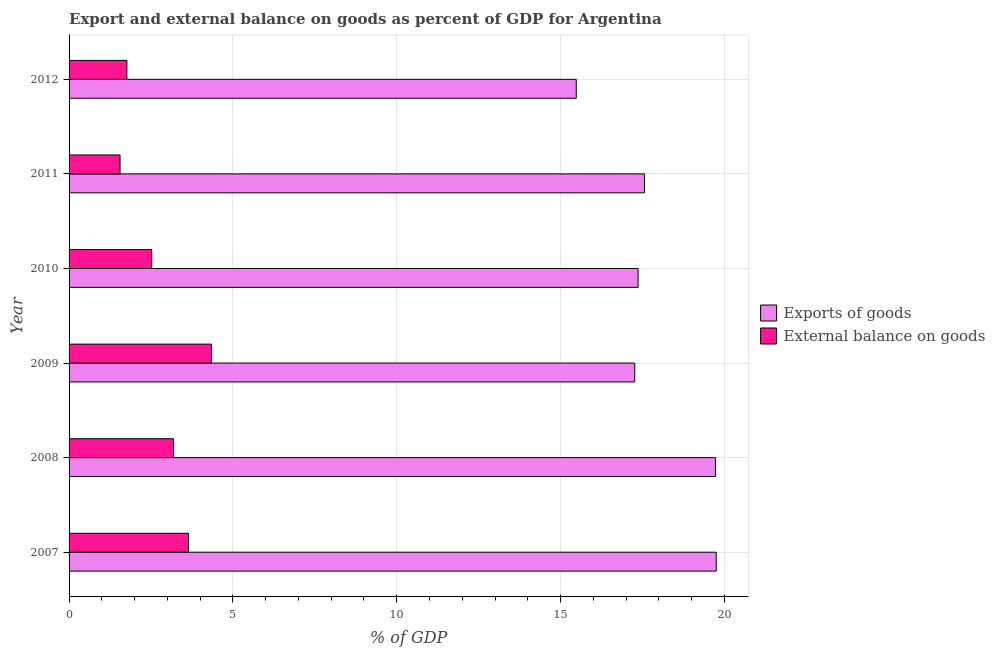How many groups of bars are there?
Offer a terse response. 6. Are the number of bars per tick equal to the number of legend labels?
Give a very brief answer. Yes. Are the number of bars on each tick of the Y-axis equal?
Offer a very short reply. Yes. How many bars are there on the 6th tick from the bottom?
Your answer should be compact. 2. What is the label of the 5th group of bars from the top?
Offer a terse response. 2008. In how many cases, is the number of bars for a given year not equal to the number of legend labels?
Your answer should be very brief. 0. What is the export of goods as percentage of gdp in 2009?
Offer a terse response. 17.27. Across all years, what is the maximum export of goods as percentage of gdp?
Your answer should be compact. 19.75. Across all years, what is the minimum export of goods as percentage of gdp?
Give a very brief answer. 15.48. In which year was the external balance on goods as percentage of gdp maximum?
Your answer should be compact. 2009. In which year was the external balance on goods as percentage of gdp minimum?
Your answer should be very brief. 2011. What is the total export of goods as percentage of gdp in the graph?
Provide a short and direct response. 107.16. What is the difference between the external balance on goods as percentage of gdp in 2008 and that in 2011?
Your answer should be very brief. 1.63. What is the difference between the export of goods as percentage of gdp in 2012 and the external balance on goods as percentage of gdp in 2007?
Give a very brief answer. 11.84. What is the average export of goods as percentage of gdp per year?
Keep it short and to the point. 17.86. In the year 2009, what is the difference between the external balance on goods as percentage of gdp and export of goods as percentage of gdp?
Offer a terse response. -12.92. What is the ratio of the export of goods as percentage of gdp in 2008 to that in 2009?
Your answer should be compact. 1.14. What is the difference between the highest and the second highest external balance on goods as percentage of gdp?
Offer a terse response. 0.7. What is the difference between the highest and the lowest external balance on goods as percentage of gdp?
Ensure brevity in your answer.  2.79. In how many years, is the export of goods as percentage of gdp greater than the average export of goods as percentage of gdp taken over all years?
Your answer should be compact. 2. What does the 1st bar from the top in 2012 represents?
Your answer should be very brief. External balance on goods. What does the 1st bar from the bottom in 2012 represents?
Provide a short and direct response. Exports of goods. Are all the bars in the graph horizontal?
Give a very brief answer. Yes. How many years are there in the graph?
Your answer should be compact. 6. Are the values on the major ticks of X-axis written in scientific E-notation?
Provide a short and direct response. No. Does the graph contain any zero values?
Ensure brevity in your answer.  No. How are the legend labels stacked?
Make the answer very short. Vertical. What is the title of the graph?
Provide a short and direct response. Export and external balance on goods as percent of GDP for Argentina. Does "Electricity and heat production" appear as one of the legend labels in the graph?
Make the answer very short. No. What is the label or title of the X-axis?
Give a very brief answer. % of GDP. What is the label or title of the Y-axis?
Make the answer very short. Year. What is the % of GDP in Exports of goods in 2007?
Give a very brief answer. 19.75. What is the % of GDP of External balance on goods in 2007?
Give a very brief answer. 3.64. What is the % of GDP of Exports of goods in 2008?
Keep it short and to the point. 19.73. What is the % of GDP of External balance on goods in 2008?
Keep it short and to the point. 3.19. What is the % of GDP of Exports of goods in 2009?
Offer a very short reply. 17.27. What is the % of GDP of External balance on goods in 2009?
Give a very brief answer. 4.35. What is the % of GDP of Exports of goods in 2010?
Provide a succinct answer. 17.37. What is the % of GDP in External balance on goods in 2010?
Provide a short and direct response. 2.52. What is the % of GDP in Exports of goods in 2011?
Give a very brief answer. 17.56. What is the % of GDP in External balance on goods in 2011?
Your response must be concise. 1.56. What is the % of GDP in Exports of goods in 2012?
Your response must be concise. 15.48. What is the % of GDP in External balance on goods in 2012?
Your response must be concise. 1.76. Across all years, what is the maximum % of GDP in Exports of goods?
Offer a terse response. 19.75. Across all years, what is the maximum % of GDP of External balance on goods?
Your answer should be very brief. 4.35. Across all years, what is the minimum % of GDP in Exports of goods?
Offer a very short reply. 15.48. Across all years, what is the minimum % of GDP in External balance on goods?
Your answer should be compact. 1.56. What is the total % of GDP of Exports of goods in the graph?
Make the answer very short. 107.16. What is the total % of GDP of External balance on goods in the graph?
Provide a short and direct response. 17.02. What is the difference between the % of GDP in Exports of goods in 2007 and that in 2008?
Make the answer very short. 0.02. What is the difference between the % of GDP of External balance on goods in 2007 and that in 2008?
Make the answer very short. 0.46. What is the difference between the % of GDP of Exports of goods in 2007 and that in 2009?
Make the answer very short. 2.49. What is the difference between the % of GDP of External balance on goods in 2007 and that in 2009?
Give a very brief answer. -0.7. What is the difference between the % of GDP in Exports of goods in 2007 and that in 2010?
Provide a succinct answer. 2.39. What is the difference between the % of GDP in External balance on goods in 2007 and that in 2010?
Provide a succinct answer. 1.12. What is the difference between the % of GDP of Exports of goods in 2007 and that in 2011?
Offer a terse response. 2.19. What is the difference between the % of GDP of External balance on goods in 2007 and that in 2011?
Offer a terse response. 2.09. What is the difference between the % of GDP in Exports of goods in 2007 and that in 2012?
Give a very brief answer. 4.27. What is the difference between the % of GDP in External balance on goods in 2007 and that in 2012?
Give a very brief answer. 1.88. What is the difference between the % of GDP of Exports of goods in 2008 and that in 2009?
Give a very brief answer. 2.46. What is the difference between the % of GDP in External balance on goods in 2008 and that in 2009?
Provide a short and direct response. -1.16. What is the difference between the % of GDP of Exports of goods in 2008 and that in 2010?
Give a very brief answer. 2.36. What is the difference between the % of GDP of External balance on goods in 2008 and that in 2010?
Provide a succinct answer. 0.66. What is the difference between the % of GDP in Exports of goods in 2008 and that in 2011?
Keep it short and to the point. 2.17. What is the difference between the % of GDP in External balance on goods in 2008 and that in 2011?
Ensure brevity in your answer.  1.63. What is the difference between the % of GDP of Exports of goods in 2008 and that in 2012?
Provide a succinct answer. 4.25. What is the difference between the % of GDP in External balance on goods in 2008 and that in 2012?
Offer a terse response. 1.42. What is the difference between the % of GDP of Exports of goods in 2009 and that in 2010?
Make the answer very short. -0.1. What is the difference between the % of GDP of External balance on goods in 2009 and that in 2010?
Offer a very short reply. 1.82. What is the difference between the % of GDP in Exports of goods in 2009 and that in 2011?
Ensure brevity in your answer.  -0.3. What is the difference between the % of GDP of External balance on goods in 2009 and that in 2011?
Make the answer very short. 2.79. What is the difference between the % of GDP of Exports of goods in 2009 and that in 2012?
Your answer should be very brief. 1.78. What is the difference between the % of GDP in External balance on goods in 2009 and that in 2012?
Make the answer very short. 2.58. What is the difference between the % of GDP in Exports of goods in 2010 and that in 2011?
Keep it short and to the point. -0.2. What is the difference between the % of GDP in Exports of goods in 2010 and that in 2012?
Offer a very short reply. 1.89. What is the difference between the % of GDP in External balance on goods in 2010 and that in 2012?
Your response must be concise. 0.76. What is the difference between the % of GDP in Exports of goods in 2011 and that in 2012?
Your answer should be compact. 2.08. What is the difference between the % of GDP in External balance on goods in 2011 and that in 2012?
Make the answer very short. -0.21. What is the difference between the % of GDP of Exports of goods in 2007 and the % of GDP of External balance on goods in 2008?
Your answer should be compact. 16.57. What is the difference between the % of GDP in Exports of goods in 2007 and the % of GDP in External balance on goods in 2009?
Provide a short and direct response. 15.41. What is the difference between the % of GDP in Exports of goods in 2007 and the % of GDP in External balance on goods in 2010?
Make the answer very short. 17.23. What is the difference between the % of GDP of Exports of goods in 2007 and the % of GDP of External balance on goods in 2011?
Your response must be concise. 18.2. What is the difference between the % of GDP of Exports of goods in 2007 and the % of GDP of External balance on goods in 2012?
Provide a succinct answer. 17.99. What is the difference between the % of GDP of Exports of goods in 2008 and the % of GDP of External balance on goods in 2009?
Keep it short and to the point. 15.38. What is the difference between the % of GDP in Exports of goods in 2008 and the % of GDP in External balance on goods in 2010?
Make the answer very short. 17.21. What is the difference between the % of GDP in Exports of goods in 2008 and the % of GDP in External balance on goods in 2011?
Offer a terse response. 18.17. What is the difference between the % of GDP of Exports of goods in 2008 and the % of GDP of External balance on goods in 2012?
Give a very brief answer. 17.96. What is the difference between the % of GDP in Exports of goods in 2009 and the % of GDP in External balance on goods in 2010?
Give a very brief answer. 14.74. What is the difference between the % of GDP of Exports of goods in 2009 and the % of GDP of External balance on goods in 2011?
Give a very brief answer. 15.71. What is the difference between the % of GDP of Exports of goods in 2009 and the % of GDP of External balance on goods in 2012?
Offer a very short reply. 15.5. What is the difference between the % of GDP of Exports of goods in 2010 and the % of GDP of External balance on goods in 2011?
Your answer should be compact. 15.81. What is the difference between the % of GDP of Exports of goods in 2010 and the % of GDP of External balance on goods in 2012?
Your answer should be compact. 15.6. What is the difference between the % of GDP of Exports of goods in 2011 and the % of GDP of External balance on goods in 2012?
Provide a succinct answer. 15.8. What is the average % of GDP of Exports of goods per year?
Your response must be concise. 17.86. What is the average % of GDP of External balance on goods per year?
Offer a very short reply. 2.84. In the year 2007, what is the difference between the % of GDP of Exports of goods and % of GDP of External balance on goods?
Your response must be concise. 16.11. In the year 2008, what is the difference between the % of GDP in Exports of goods and % of GDP in External balance on goods?
Your answer should be very brief. 16.54. In the year 2009, what is the difference between the % of GDP in Exports of goods and % of GDP in External balance on goods?
Offer a terse response. 12.92. In the year 2010, what is the difference between the % of GDP of Exports of goods and % of GDP of External balance on goods?
Ensure brevity in your answer.  14.84. In the year 2011, what is the difference between the % of GDP in Exports of goods and % of GDP in External balance on goods?
Ensure brevity in your answer.  16.01. In the year 2012, what is the difference between the % of GDP of Exports of goods and % of GDP of External balance on goods?
Provide a succinct answer. 13.72. What is the ratio of the % of GDP in External balance on goods in 2007 to that in 2008?
Provide a succinct answer. 1.14. What is the ratio of the % of GDP of Exports of goods in 2007 to that in 2009?
Make the answer very short. 1.14. What is the ratio of the % of GDP of External balance on goods in 2007 to that in 2009?
Offer a terse response. 0.84. What is the ratio of the % of GDP of Exports of goods in 2007 to that in 2010?
Your answer should be compact. 1.14. What is the ratio of the % of GDP in External balance on goods in 2007 to that in 2010?
Provide a succinct answer. 1.44. What is the ratio of the % of GDP of Exports of goods in 2007 to that in 2011?
Give a very brief answer. 1.12. What is the ratio of the % of GDP in External balance on goods in 2007 to that in 2011?
Keep it short and to the point. 2.34. What is the ratio of the % of GDP in Exports of goods in 2007 to that in 2012?
Offer a very short reply. 1.28. What is the ratio of the % of GDP of External balance on goods in 2007 to that in 2012?
Offer a terse response. 2.07. What is the ratio of the % of GDP in Exports of goods in 2008 to that in 2009?
Your answer should be compact. 1.14. What is the ratio of the % of GDP in External balance on goods in 2008 to that in 2009?
Your answer should be compact. 0.73. What is the ratio of the % of GDP of Exports of goods in 2008 to that in 2010?
Your response must be concise. 1.14. What is the ratio of the % of GDP of External balance on goods in 2008 to that in 2010?
Offer a terse response. 1.26. What is the ratio of the % of GDP in Exports of goods in 2008 to that in 2011?
Your answer should be compact. 1.12. What is the ratio of the % of GDP in External balance on goods in 2008 to that in 2011?
Provide a succinct answer. 2.05. What is the ratio of the % of GDP in Exports of goods in 2008 to that in 2012?
Provide a succinct answer. 1.27. What is the ratio of the % of GDP of External balance on goods in 2008 to that in 2012?
Offer a very short reply. 1.81. What is the ratio of the % of GDP of Exports of goods in 2009 to that in 2010?
Make the answer very short. 0.99. What is the ratio of the % of GDP in External balance on goods in 2009 to that in 2010?
Provide a succinct answer. 1.72. What is the ratio of the % of GDP in External balance on goods in 2009 to that in 2011?
Provide a short and direct response. 2.79. What is the ratio of the % of GDP of Exports of goods in 2009 to that in 2012?
Provide a succinct answer. 1.12. What is the ratio of the % of GDP in External balance on goods in 2009 to that in 2012?
Ensure brevity in your answer.  2.46. What is the ratio of the % of GDP in Exports of goods in 2010 to that in 2011?
Your answer should be very brief. 0.99. What is the ratio of the % of GDP in External balance on goods in 2010 to that in 2011?
Your response must be concise. 1.62. What is the ratio of the % of GDP in Exports of goods in 2010 to that in 2012?
Give a very brief answer. 1.12. What is the ratio of the % of GDP in External balance on goods in 2010 to that in 2012?
Offer a terse response. 1.43. What is the ratio of the % of GDP of Exports of goods in 2011 to that in 2012?
Offer a very short reply. 1.13. What is the ratio of the % of GDP of External balance on goods in 2011 to that in 2012?
Your response must be concise. 0.88. What is the difference between the highest and the second highest % of GDP in Exports of goods?
Offer a terse response. 0.02. What is the difference between the highest and the second highest % of GDP of External balance on goods?
Give a very brief answer. 0.7. What is the difference between the highest and the lowest % of GDP of Exports of goods?
Keep it short and to the point. 4.27. What is the difference between the highest and the lowest % of GDP in External balance on goods?
Offer a terse response. 2.79. 